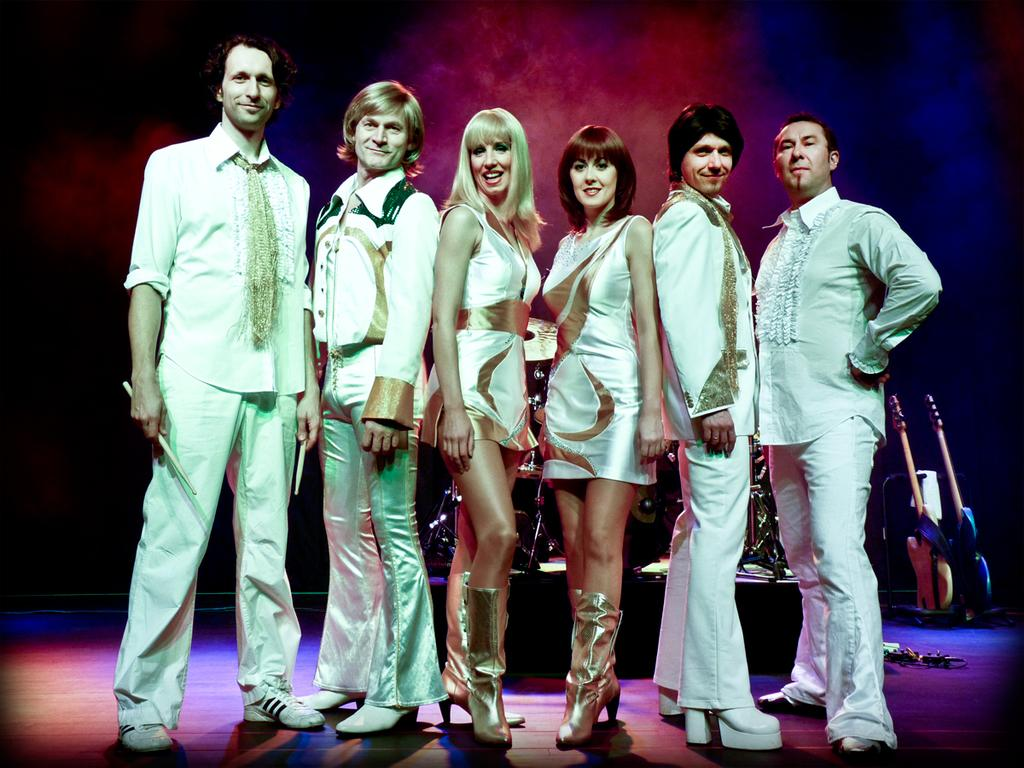How many people are in the image? There is a group of persons in the image. What are the people wearing in the image? The persons are wearing similar color dresses. What are the people doing in the image? The persons are standing and posing for a photograph. What can be seen in the background of the image? There are musical instruments in the background of the image. What type of brake can be seen in the image? There is no brake present in the image. What is the aftermath of the event in the image? The image does not depict an event, so there is no aftermath to describe. 